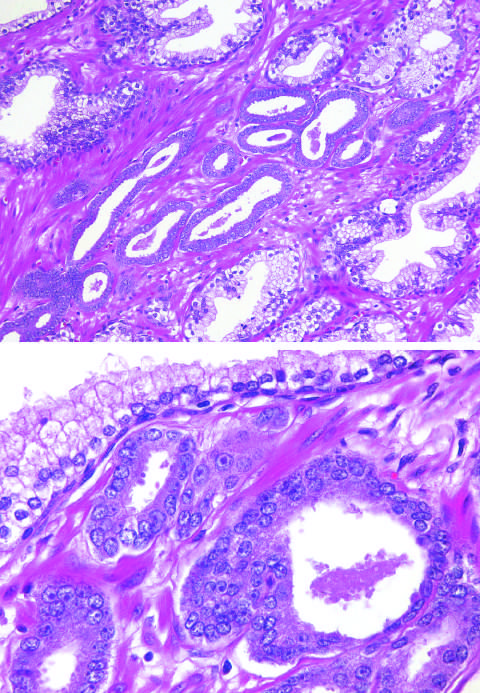what is are the small glands crowded in between?
Answer the question using a single word or phrase. Larger benign glands 